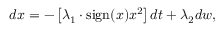Convert formula to latex. <formula><loc_0><loc_0><loc_500><loc_500>\begin{array} { r } { d x = - \left [ \lambda _ { 1 } \cdot s i g n ( x ) x ^ { 2 } \right ] d t + \lambda _ { 2 } d w , } \end{array}</formula> 